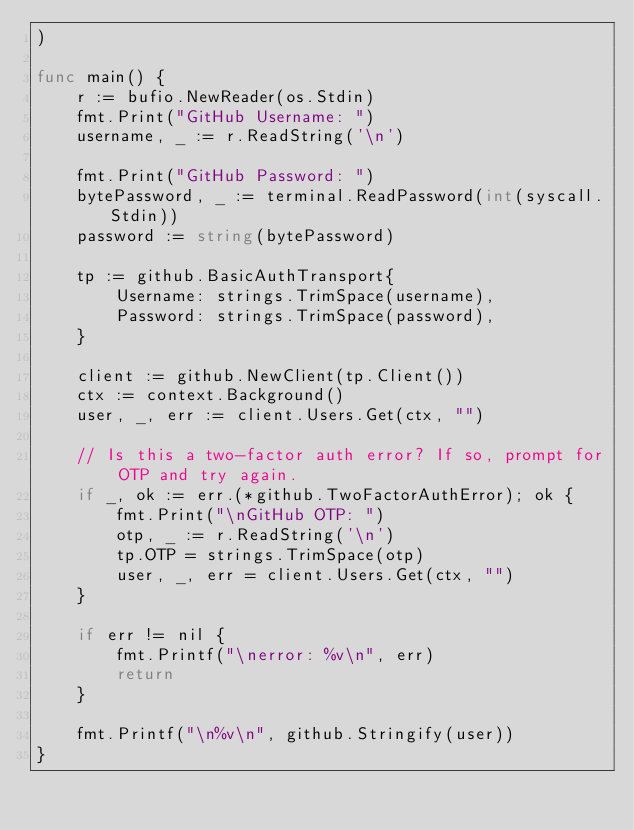<code> <loc_0><loc_0><loc_500><loc_500><_Go_>)

func main() {
	r := bufio.NewReader(os.Stdin)
	fmt.Print("GitHub Username: ")
	username, _ := r.ReadString('\n')

	fmt.Print("GitHub Password: ")
	bytePassword, _ := terminal.ReadPassword(int(syscall.Stdin))
	password := string(bytePassword)

	tp := github.BasicAuthTransport{
		Username: strings.TrimSpace(username),
		Password: strings.TrimSpace(password),
	}

	client := github.NewClient(tp.Client())
	ctx := context.Background()
	user, _, err := client.Users.Get(ctx, "")

	// Is this a two-factor auth error? If so, prompt for OTP and try again.
	if _, ok := err.(*github.TwoFactorAuthError); ok {
		fmt.Print("\nGitHub OTP: ")
		otp, _ := r.ReadString('\n')
		tp.OTP = strings.TrimSpace(otp)
		user, _, err = client.Users.Get(ctx, "")
	}

	if err != nil {
		fmt.Printf("\nerror: %v\n", err)
		return
	}

	fmt.Printf("\n%v\n", github.Stringify(user))
}
</code> 